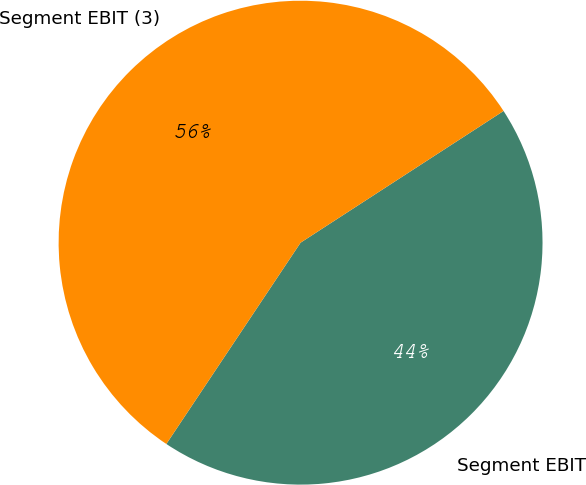<chart> <loc_0><loc_0><loc_500><loc_500><pie_chart><fcel>Segment EBIT<fcel>Segment EBIT (3)<nl><fcel>43.52%<fcel>56.48%<nl></chart> 